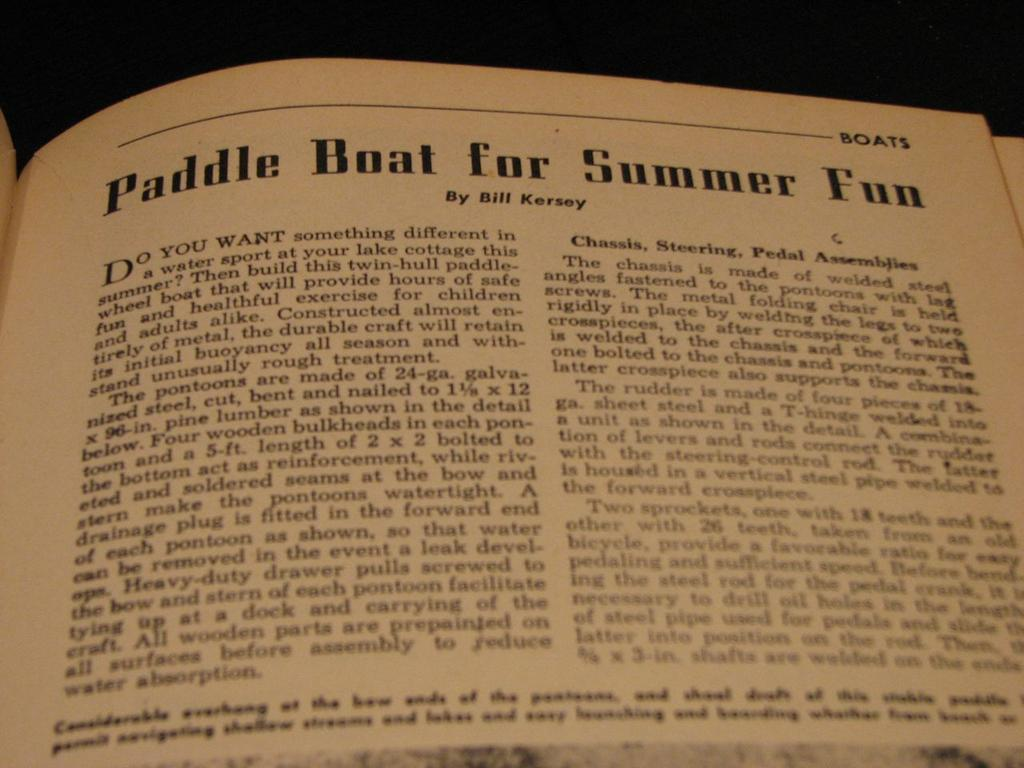<image>
Provide a brief description of the given image. Paddle Boat for Summer Fun, a book about boats by Bill kersey. It talks about the assembly and execution of paddle boats. 